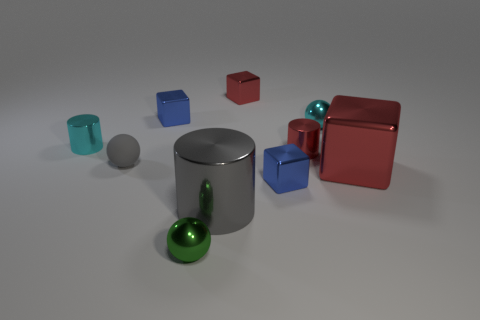How many blue cubes must be subtracted to get 1 blue cubes? 1 Subtract 1 blocks. How many blocks are left? 3 Subtract all cylinders. How many objects are left? 7 Add 9 gray cylinders. How many gray cylinders are left? 10 Add 6 red shiny cubes. How many red shiny cubes exist? 8 Subtract 1 cyan balls. How many objects are left? 9 Subtract all tiny red metallic cubes. Subtract all small balls. How many objects are left? 6 